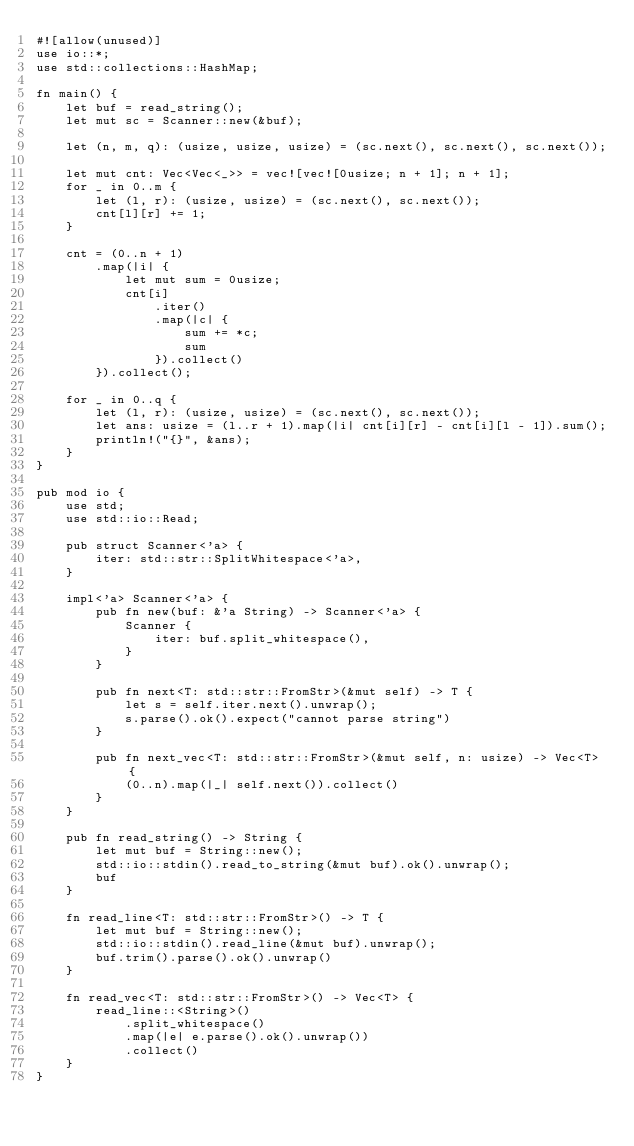<code> <loc_0><loc_0><loc_500><loc_500><_Rust_>#![allow(unused)]
use io::*;
use std::collections::HashMap;

fn main() {
    let buf = read_string();
    let mut sc = Scanner::new(&buf);

    let (n, m, q): (usize, usize, usize) = (sc.next(), sc.next(), sc.next());

    let mut cnt: Vec<Vec<_>> = vec![vec![0usize; n + 1]; n + 1];
    for _ in 0..m {
        let (l, r): (usize, usize) = (sc.next(), sc.next());
        cnt[l][r] += 1;
    }

    cnt = (0..n + 1)
        .map(|i| {
            let mut sum = 0usize;
            cnt[i]
                .iter()
                .map(|c| {
                    sum += *c;
                    sum
                }).collect()
        }).collect();

    for _ in 0..q {
        let (l, r): (usize, usize) = (sc.next(), sc.next());
        let ans: usize = (l..r + 1).map(|i| cnt[i][r] - cnt[i][l - 1]).sum();
        println!("{}", &ans);
    }
}

pub mod io {
    use std;
    use std::io::Read;

    pub struct Scanner<'a> {
        iter: std::str::SplitWhitespace<'a>,
    }

    impl<'a> Scanner<'a> {
        pub fn new(buf: &'a String) -> Scanner<'a> {
            Scanner {
                iter: buf.split_whitespace(),
            }
        }

        pub fn next<T: std::str::FromStr>(&mut self) -> T {
            let s = self.iter.next().unwrap();
            s.parse().ok().expect("cannot parse string")
        }

        pub fn next_vec<T: std::str::FromStr>(&mut self, n: usize) -> Vec<T> {
            (0..n).map(|_| self.next()).collect()
        }
    }

    pub fn read_string() -> String {
        let mut buf = String::new();
        std::io::stdin().read_to_string(&mut buf).ok().unwrap();
        buf
    }

    fn read_line<T: std::str::FromStr>() -> T {
        let mut buf = String::new();
        std::io::stdin().read_line(&mut buf).unwrap();
        buf.trim().parse().ok().unwrap()
    }

    fn read_vec<T: std::str::FromStr>() -> Vec<T> {
        read_line::<String>()
            .split_whitespace()
            .map(|e| e.parse().ok().unwrap())
            .collect()
    }
}
</code> 